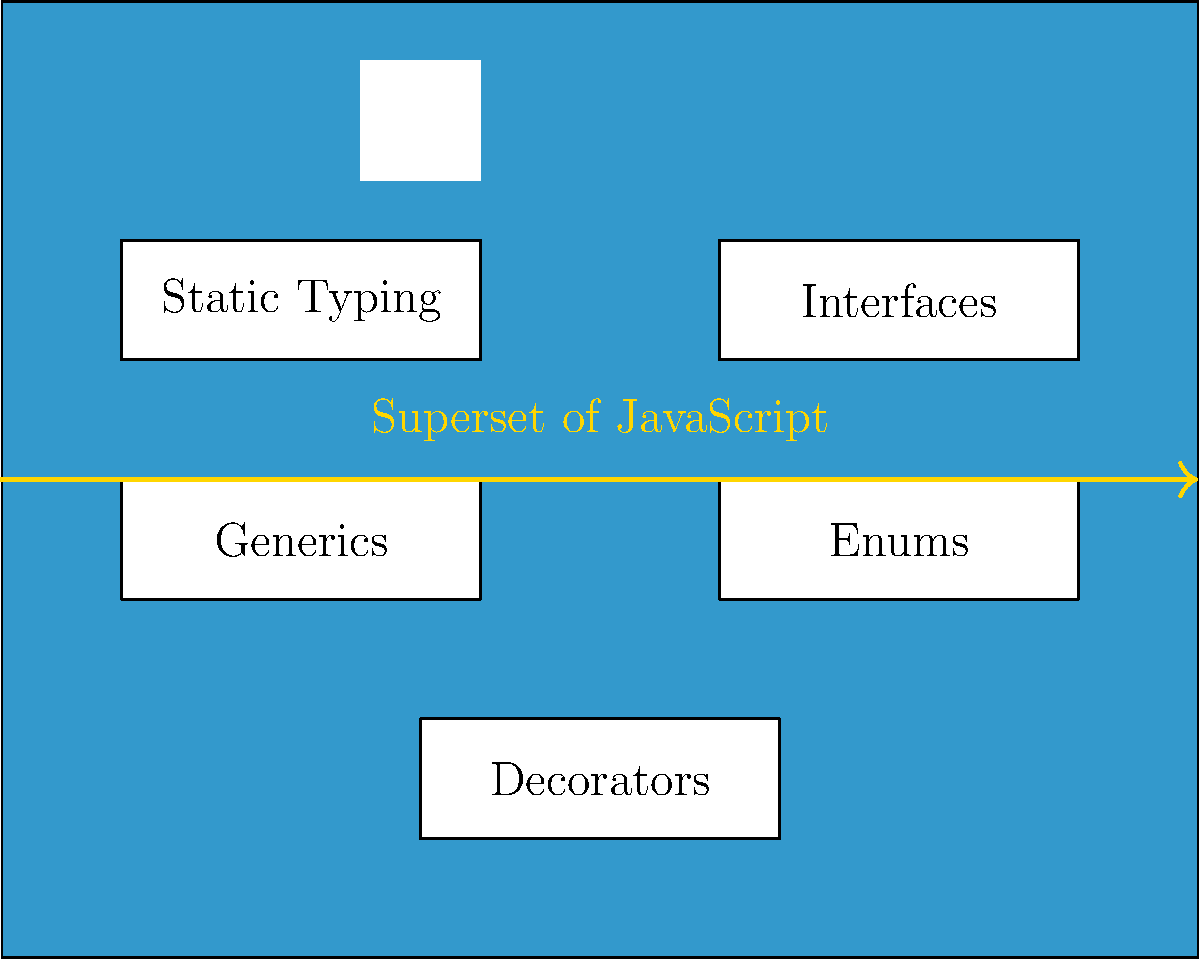In the infographic showcasing TypeScript's key features, which feature is positioned at the bottom center of the diagram? To answer this question, let's analyze the infographic step-by-step:

1. The infographic is designed as a blue rectangle representing TypeScript.
2. At the top, we see the TypeScript logo (TS).
3. There are five white boxes representing key features of TypeScript.
4. These features are arranged in a specific pattern:
   - Top left: Static Typing
   - Top right: Interfaces
   - Middle left: Generics
   - Middle right: Enums
   - Bottom center: Decorators
5. The question asks specifically about the feature positioned at the bottom center.
6. Looking at the bottom of the infographic, we can clearly see that "Decorators" is the feature placed in the center.

Therefore, the feature positioned at the bottom center of the diagram is Decorators.
Answer: Decorators 